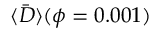<formula> <loc_0><loc_0><loc_500><loc_500>\langle \bar { D } \rangle ( \phi = 0 . 0 0 1 )</formula> 